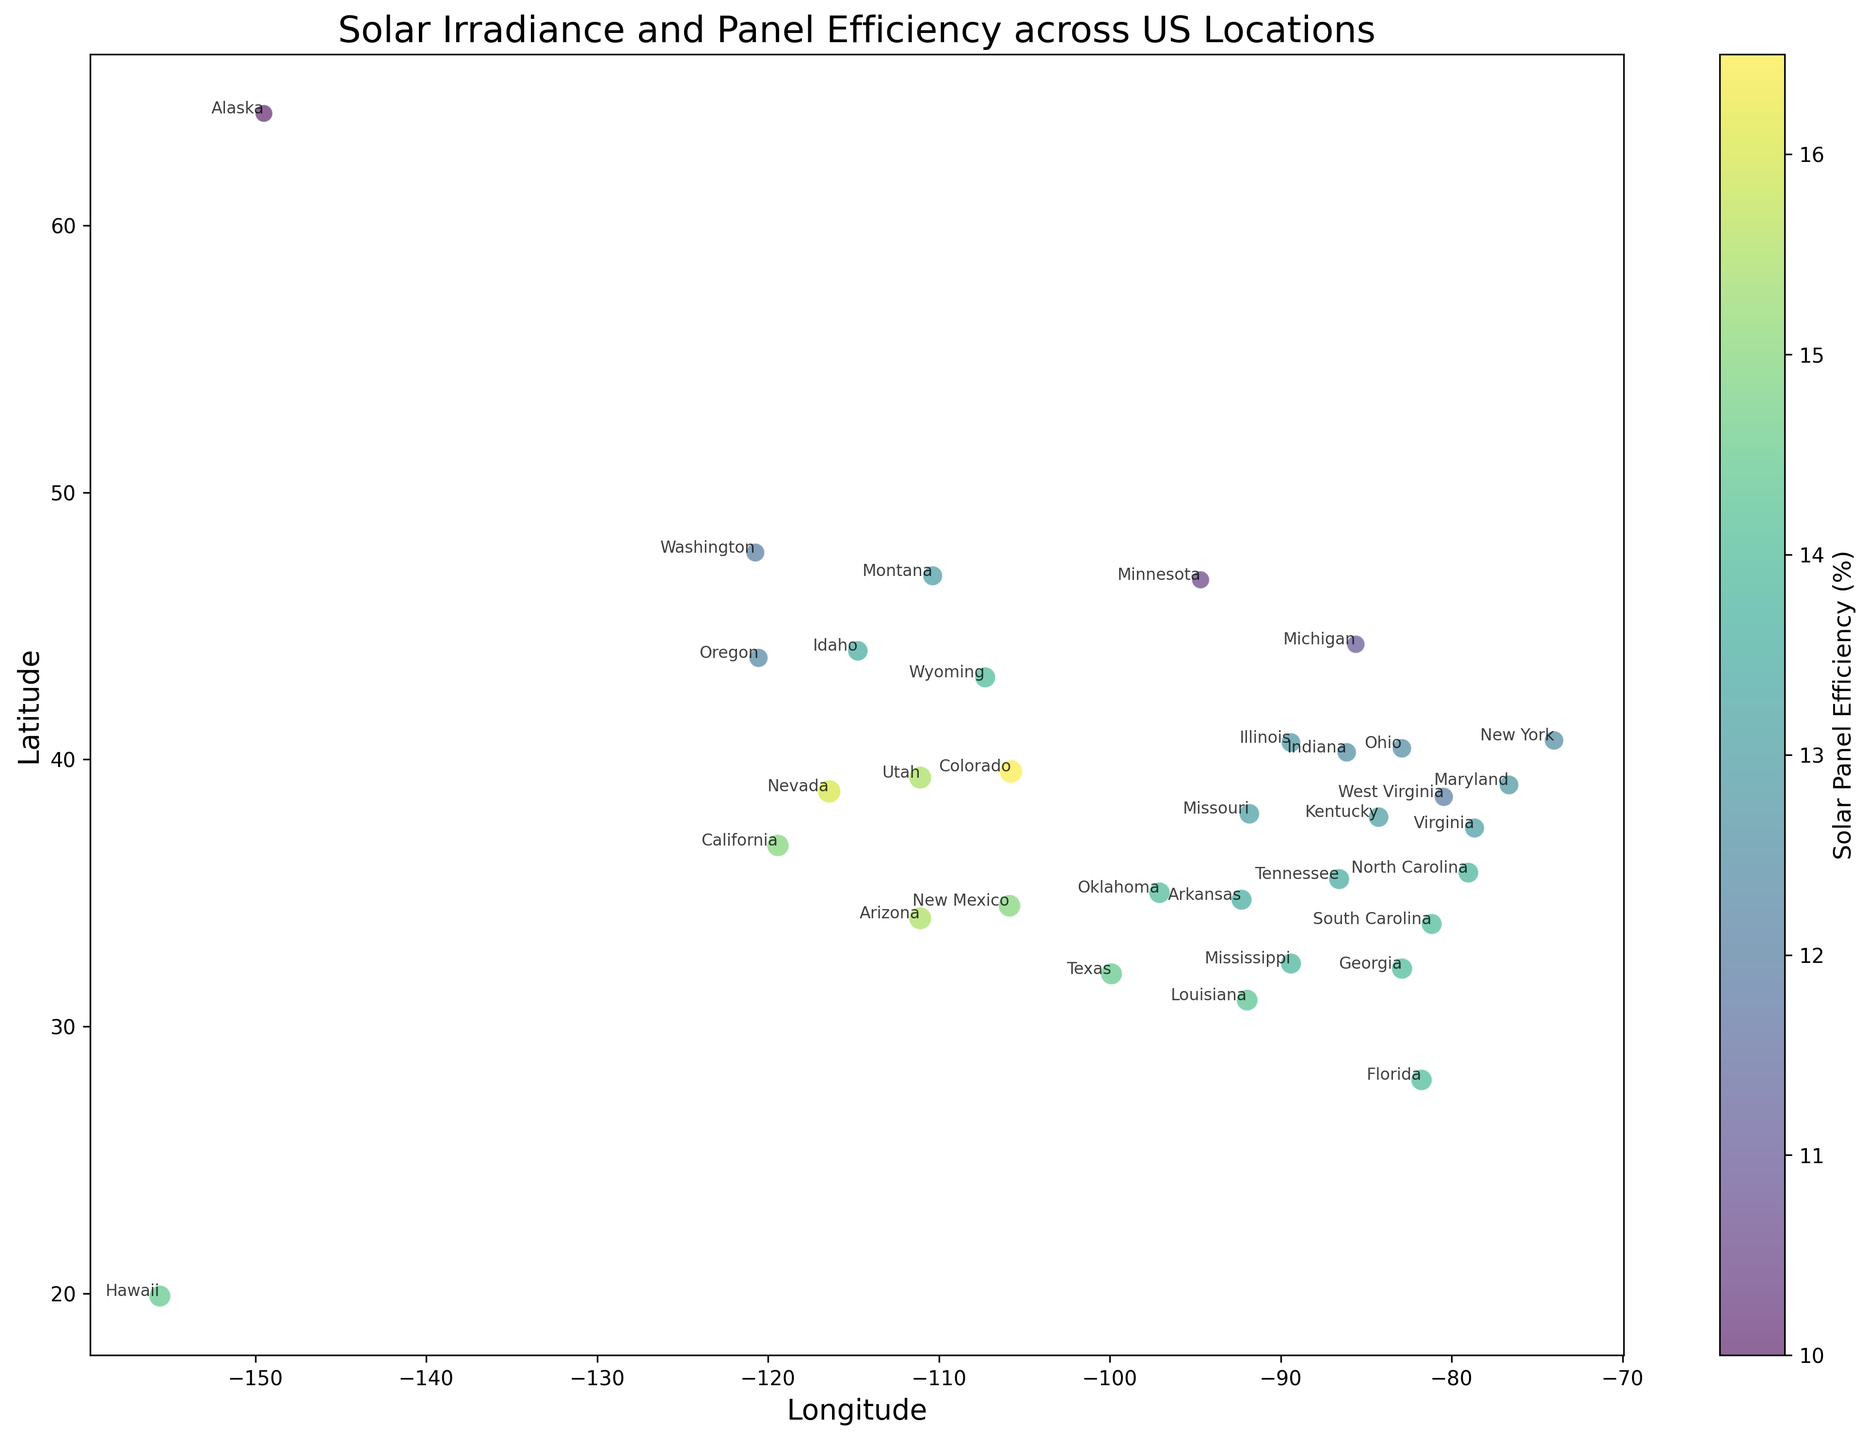Which location has the highest solar panel efficiency? By referring to the color bar and the points on the scatter plot, the brightest colors represent high solar panel efficiency. Locate the point with the brightest color.
Answer: Colorado Which location has the lowest solar irradiance? Look at the size of the dots; smaller dots represent lower solar irradiance. Identify the smallest dot on the scatter plot.
Answer: Alaska How does the solar panel efficiency of Nevada compare to that of California? Find the dots corresponding to Nevada and California. Compare their colors based on the color bar, where a brighter color indicates higher efficiency.
Answer: Nevada has higher solar panel efficiency than California Calculate the average solar panel efficiency for Arizona and Utah combined. Locate Arizona and Utah on the scatter plot, note their solar panel efficiencies, and then compute the average: (15.5 + 15.5) / 2.
Answer: 15.5% Which locations have solar panel efficiencies greater than 15%? Referring to the color bar, identify the dots with colors indicating greater than 15% efficiency.
Answer: Arizona, Nevada, Colorado, Utah, New Mexico Which has higher solar irradiance, Florida or Oklahoma? Compare the sizes of the dots for Florida and Oklahoma. The larger dot represents higher solar irradiance.
Answer: Oklahoma Identify the location with both the highest solar irradiance and highest solar panel efficiency. Check the scatter plot for the largest dot with the brightest color.
Answer: Colorado How does the solar irradiance of Texas compare to New York? Compare the sizes of the dots for Texas and New York. The larger dot indicates higher solar irradiance.
Answer: Texas has higher solar irradiance than New York What is the latitude range of locations with solar panel efficiencies below 12%? Identify points on the scatter plot with colors indicating efficiencies below 12% and note their latitudes.
Answer: Between latitude 46.7296 and 64.2008 Which state has a higher latitude, and what is its solar panel efficiency: Michigan or South Carolina? Look at the positions of Michigan and South Carolina on the scatter plot to determine their latitudes, then refer to their colors for efficiencies.
Answer: Michigan has a higher latitude and its solar panel efficiency is 11% 